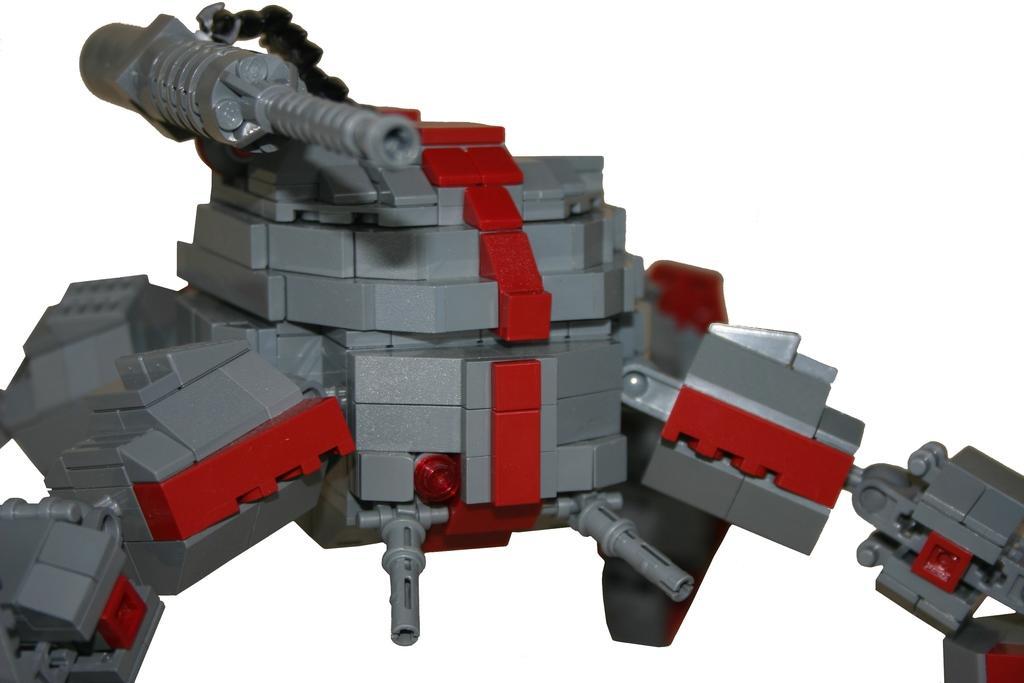How would you summarize this image in a sentence or two? In this picture I can see a toy, and there is white background. 